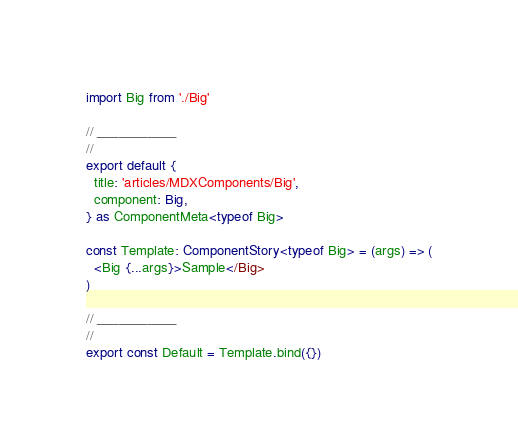Convert code to text. <code><loc_0><loc_0><loc_500><loc_500><_TypeScript_>import Big from './Big'

// ___________
//
export default {
  title: 'articles/MDXComponents/Big',
  component: Big,
} as ComponentMeta<typeof Big>

const Template: ComponentStory<typeof Big> = (args) => (
  <Big {...args}>Sample</Big>
)

// ___________
//
export const Default = Template.bind({})
</code> 